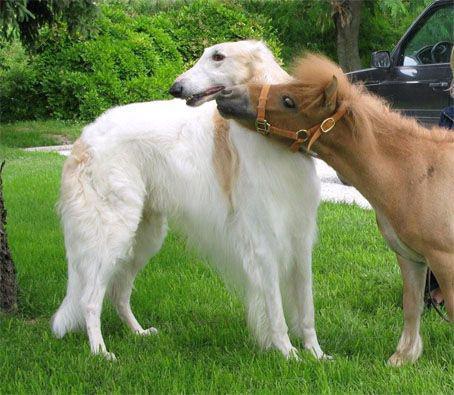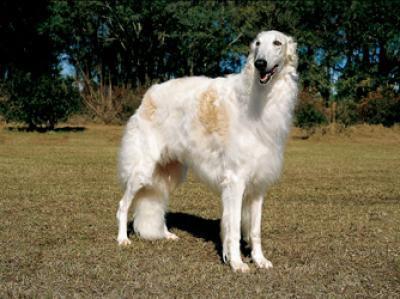The first image is the image on the left, the second image is the image on the right. For the images displayed, is the sentence "The combined images include one nearly white dog and one orange-and-white dog, and all dogs are standing in profile looking in the same direction their body is turned." factually correct? Answer yes or no. No. 